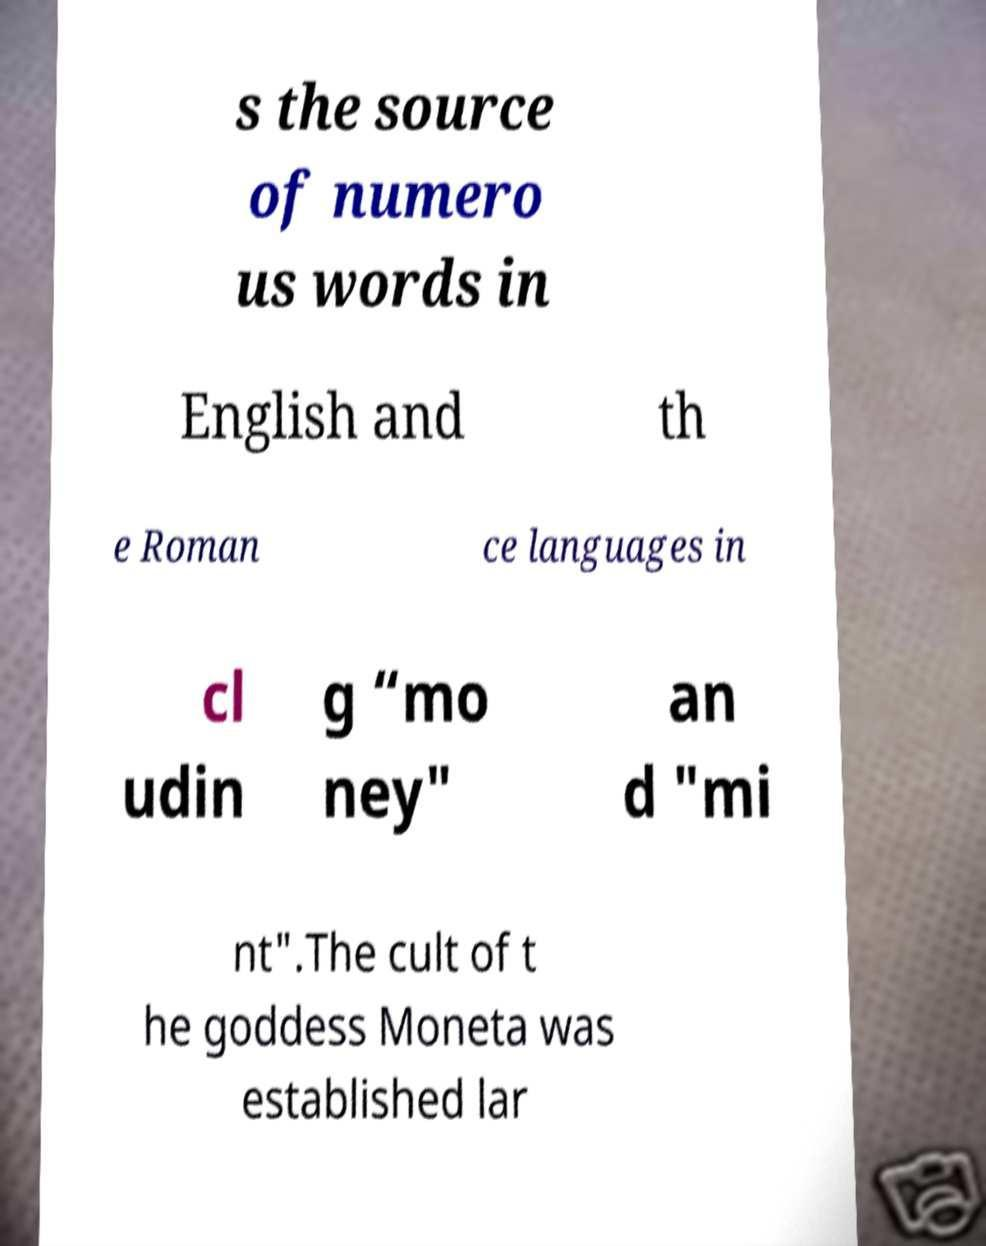Please identify and transcribe the text found in this image. s the source of numero us words in English and th e Roman ce languages in cl udin g “mo ney" an d "mi nt".The cult of t he goddess Moneta was established lar 